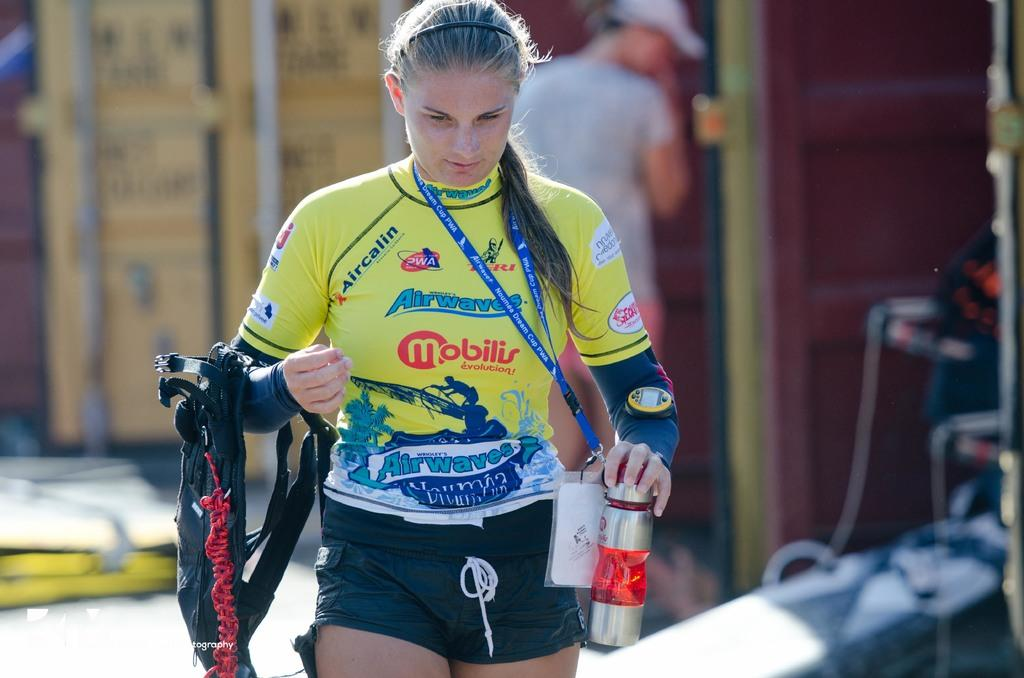Provide a one-sentence caption for the provided image. Woman wearing a colorful shirt featuring many different advertisements such as Airwaves. 